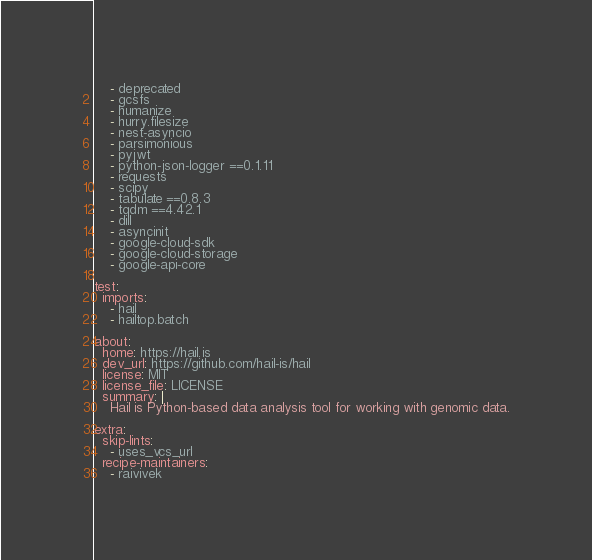<code> <loc_0><loc_0><loc_500><loc_500><_YAML_>    - deprecated
    - gcsfs
    - humanize
    - hurry.filesize
    - nest-asyncio
    - parsimonious
    - pyjwt
    - python-json-logger ==0.1.11
    - requests
    - scipy
    - tabulate ==0.8.3
    - tqdm ==4.42.1
    - dill
    - asyncinit
    - google-cloud-sdk
    - google-cloud-storage
    - google-api-core

test:
  imports:
    - hail
    - hailtop.batch

about:
  home: https://hail.is
  dev_url: https://github.com/hail-is/hail
  license: MIT
  license_file: LICENSE
  summary: |
    Hail is Python-based data analysis tool for working with genomic data.

extra:
  skip-lints:
    - uses_vcs_url
  recipe-maintainers:
    - raivivek
</code> 